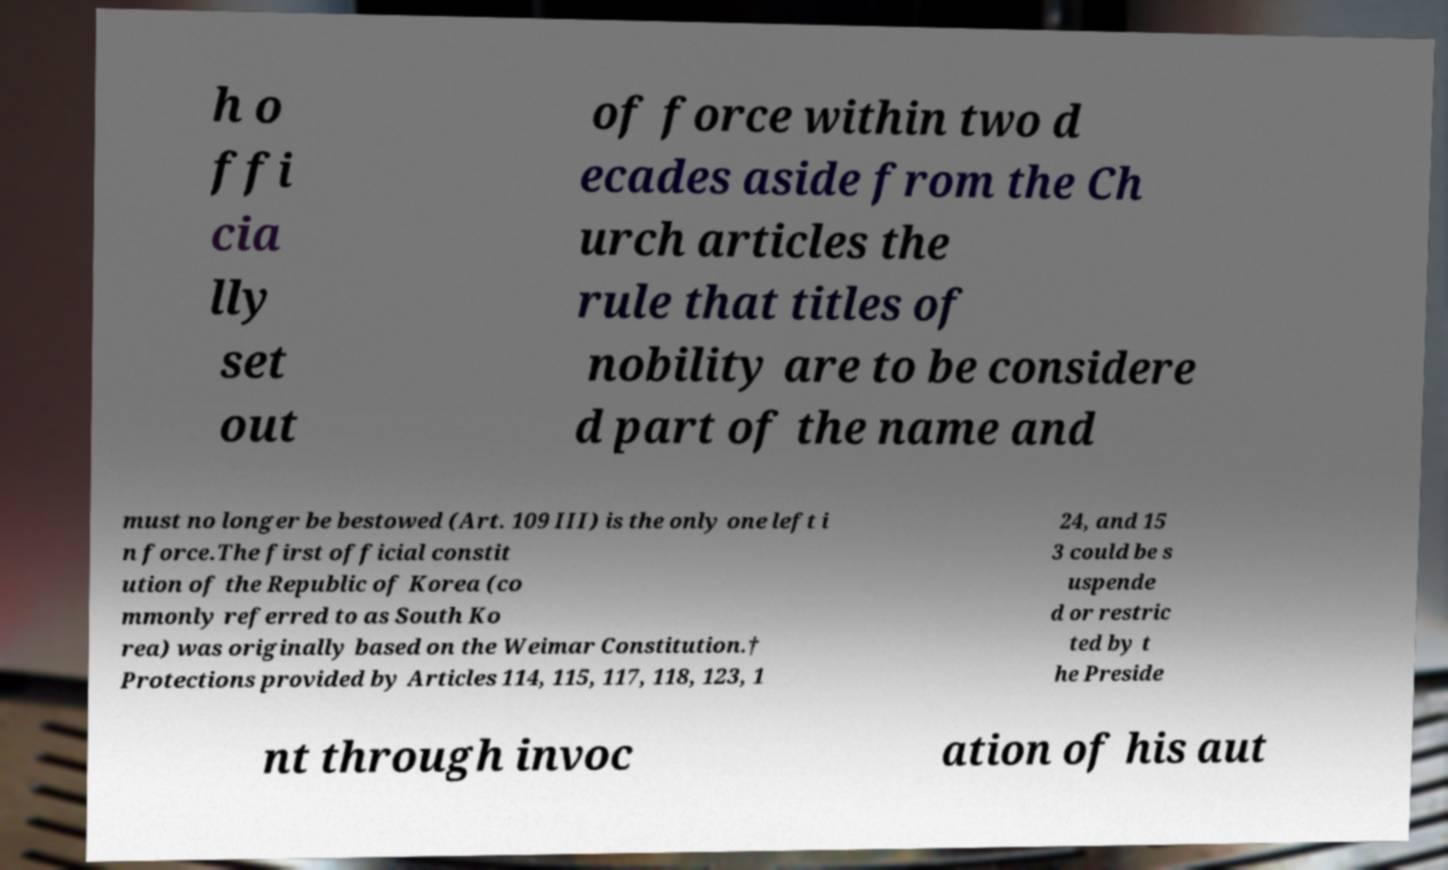Can you read and provide the text displayed in the image?This photo seems to have some interesting text. Can you extract and type it out for me? h o ffi cia lly set out of force within two d ecades aside from the Ch urch articles the rule that titles of nobility are to be considere d part of the name and must no longer be bestowed (Art. 109 III) is the only one left i n force.The first official constit ution of the Republic of Korea (co mmonly referred to as South Ko rea) was originally based on the Weimar Constitution.† Protections provided by Articles 114, 115, 117, 118, 123, 1 24, and 15 3 could be s uspende d or restric ted by t he Preside nt through invoc ation of his aut 